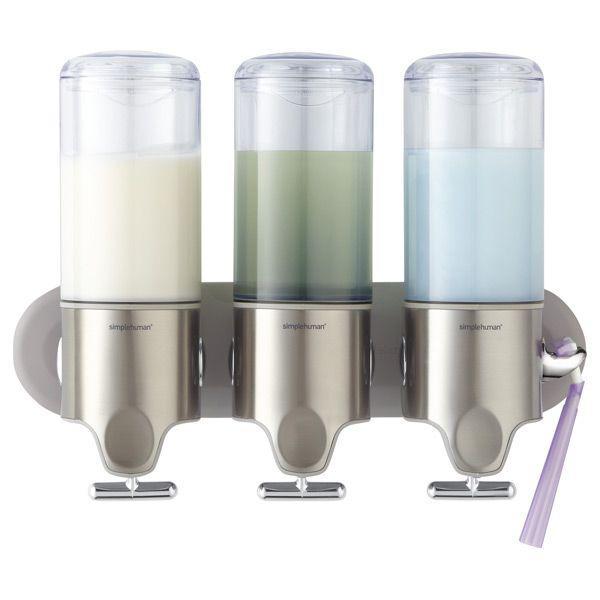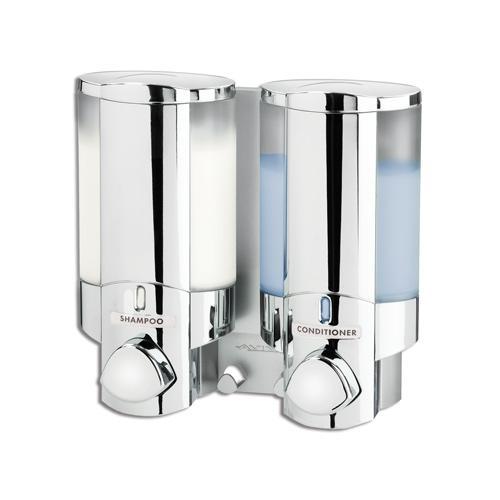The first image is the image on the left, the second image is the image on the right. Examine the images to the left and right. Is the description "There is liquid filling at least five dispensers." accurate? Answer yes or no. Yes. The first image is the image on the left, the second image is the image on the right. Considering the images on both sides, is "An image shows a trio of cylindrical dispensers that mount together, and one dispenses a white creamy-looking substance." valid? Answer yes or no. Yes. 